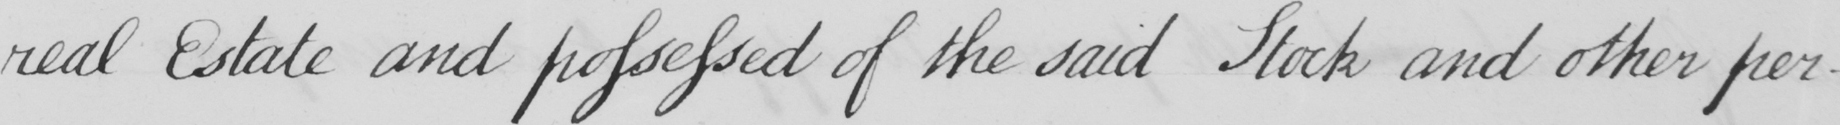Can you tell me what this handwritten text says? real Estate and possessed of the said Stock and other per- 